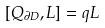Convert formula to latex. <formula><loc_0><loc_0><loc_500><loc_500>[ Q _ { \partial D } , L ] = q L</formula> 